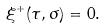<formula> <loc_0><loc_0><loc_500><loc_500>\xi ^ { + } ( \tau , \sigma ) = 0 .</formula> 